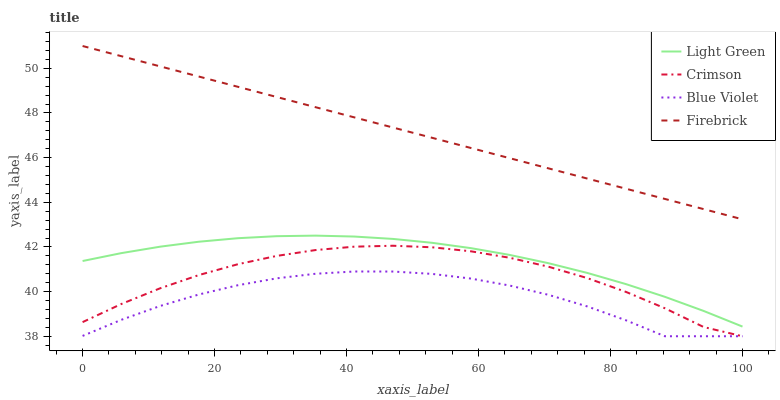Does Blue Violet have the minimum area under the curve?
Answer yes or no. Yes. Does Firebrick have the maximum area under the curve?
Answer yes or no. Yes. Does Firebrick have the minimum area under the curve?
Answer yes or no. No. Does Blue Violet have the maximum area under the curve?
Answer yes or no. No. Is Firebrick the smoothest?
Answer yes or no. Yes. Is Blue Violet the roughest?
Answer yes or no. Yes. Is Blue Violet the smoothest?
Answer yes or no. No. Is Firebrick the roughest?
Answer yes or no. No. Does Crimson have the lowest value?
Answer yes or no. Yes. Does Firebrick have the lowest value?
Answer yes or no. No. Does Firebrick have the highest value?
Answer yes or no. Yes. Does Blue Violet have the highest value?
Answer yes or no. No. Is Blue Violet less than Firebrick?
Answer yes or no. Yes. Is Firebrick greater than Light Green?
Answer yes or no. Yes. Does Crimson intersect Blue Violet?
Answer yes or no. Yes. Is Crimson less than Blue Violet?
Answer yes or no. No. Is Crimson greater than Blue Violet?
Answer yes or no. No. Does Blue Violet intersect Firebrick?
Answer yes or no. No. 